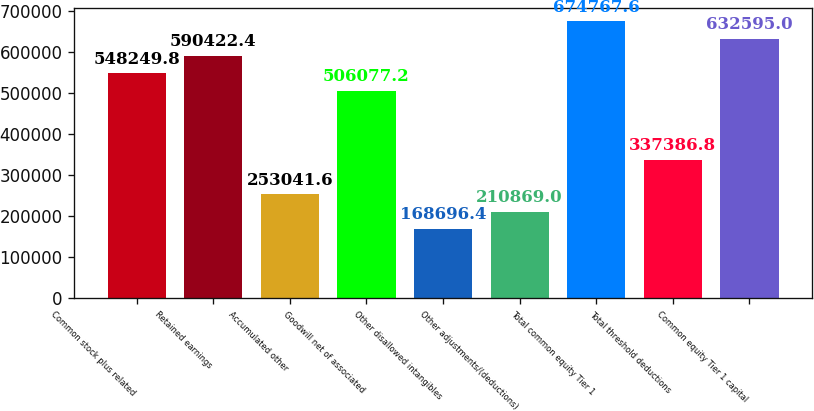Convert chart. <chart><loc_0><loc_0><loc_500><loc_500><bar_chart><fcel>Common stock plus related<fcel>Retained earnings<fcel>Accumulated other<fcel>Goodwill net of associated<fcel>Other disallowed intangibles<fcel>Other adjustments/(deductions)<fcel>Total common equity Tier 1<fcel>Total threshold deductions<fcel>Common equity Tier 1 capital<nl><fcel>548250<fcel>590422<fcel>253042<fcel>506077<fcel>168696<fcel>210869<fcel>674768<fcel>337387<fcel>632595<nl></chart> 